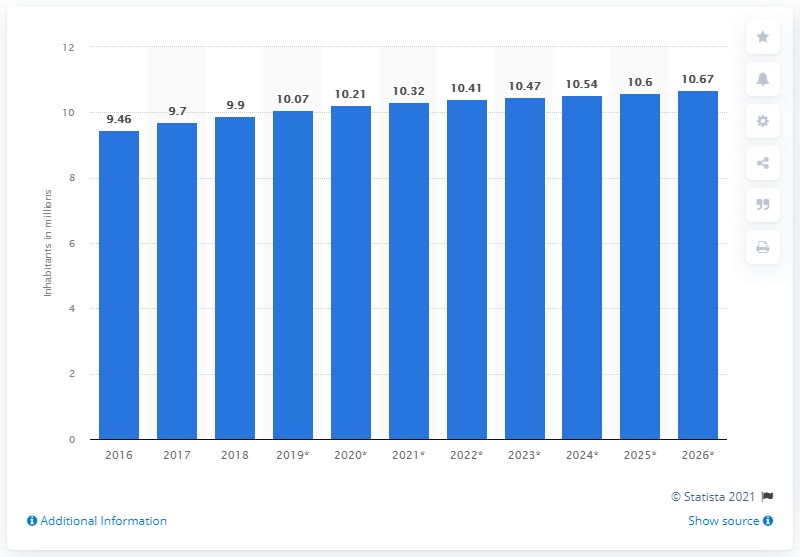Draw attention to some important aspects in this diagram. As of 2018, the population of Jordan was approximately 9.9 million people. 